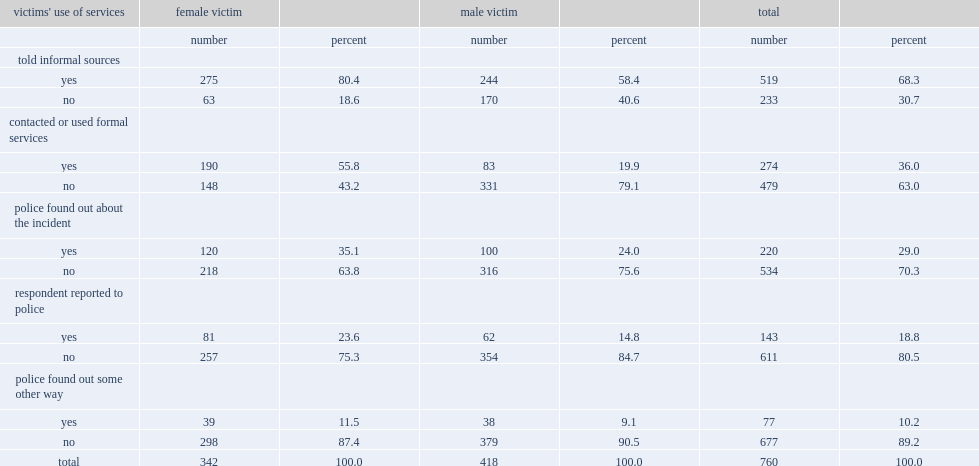Who were much more likely to discuss any such incident with someone they knew, female or male victims? Female victim. Who were more likely to contact or use formal services in 2014, female victims or male victims? Female victim. Write the full table. {'header': ["victims' use of services", 'female victim', '', 'male victim', '', 'total', ''], 'rows': [['', 'number', 'percent', 'number', 'percent', 'number', 'percent'], ['told informal sources', '', '', '', '', '', ''], ['yes', '275', '80.4', '244', '58.4', '519', '68.3'], ['no', '63', '18.6', '170', '40.6', '233', '30.7'], ['contacted or used formal services', '', '', '', '', '', ''], ['yes', '190', '55.8', '83', '19.9', '274', '36.0'], ['no', '148', '43.2', '331', '79.1', '479', '63.0'], ['police found out about the incident', '', '', '', '', '', ''], ['yes', '120', '35.1', '100', '24.0', '220', '29.0'], ['no', '218', '63.8', '316', '75.6', '534', '70.3'], ['respondent reported to police', '', '', '', '', '', ''], ['yes', '81', '23.6', '62', '14.8', '143', '18.8'], ['no', '257', '75.3', '354', '84.7', '611', '80.5'], ['police found out some other way', '', '', '', '', '', ''], ['yes', '39', '11.5', '38', '9.1', '77', '10.2'], ['no', '298', '87.4', '379', '90.5', '677', '89.2'], ['total', '342', '100.0', '418', '100.0', '760', '100.0']]} 